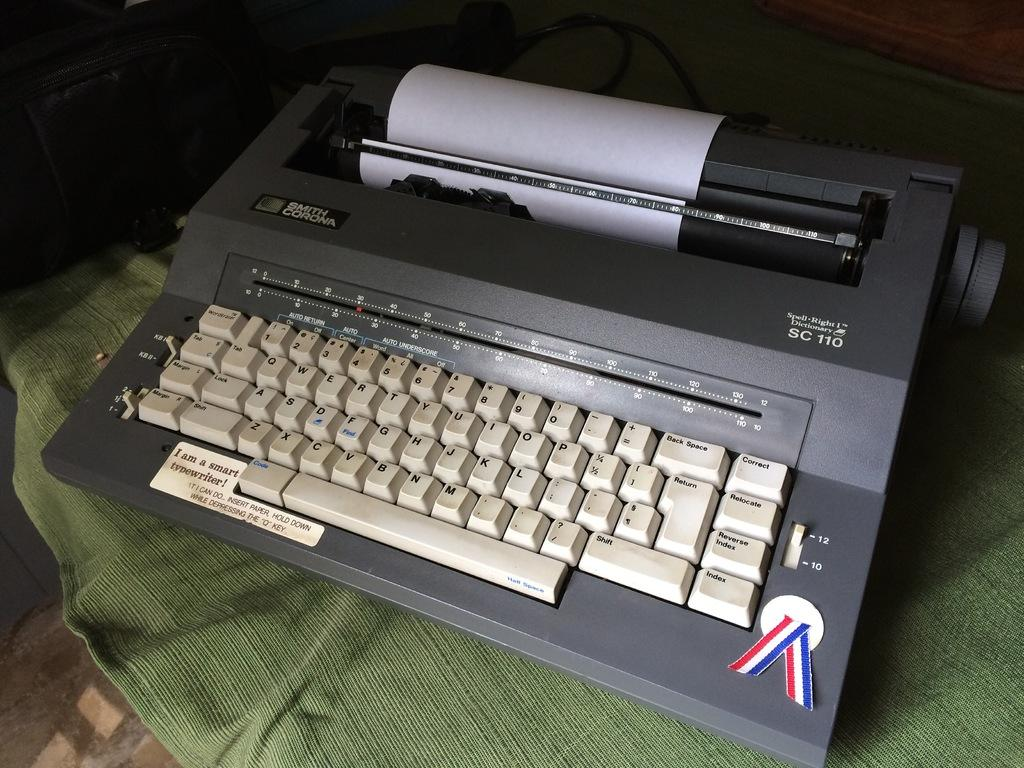<image>
Give a short and clear explanation of the subsequent image. A Smith Corona electric typewriter is loaded with paper and ready to use. 